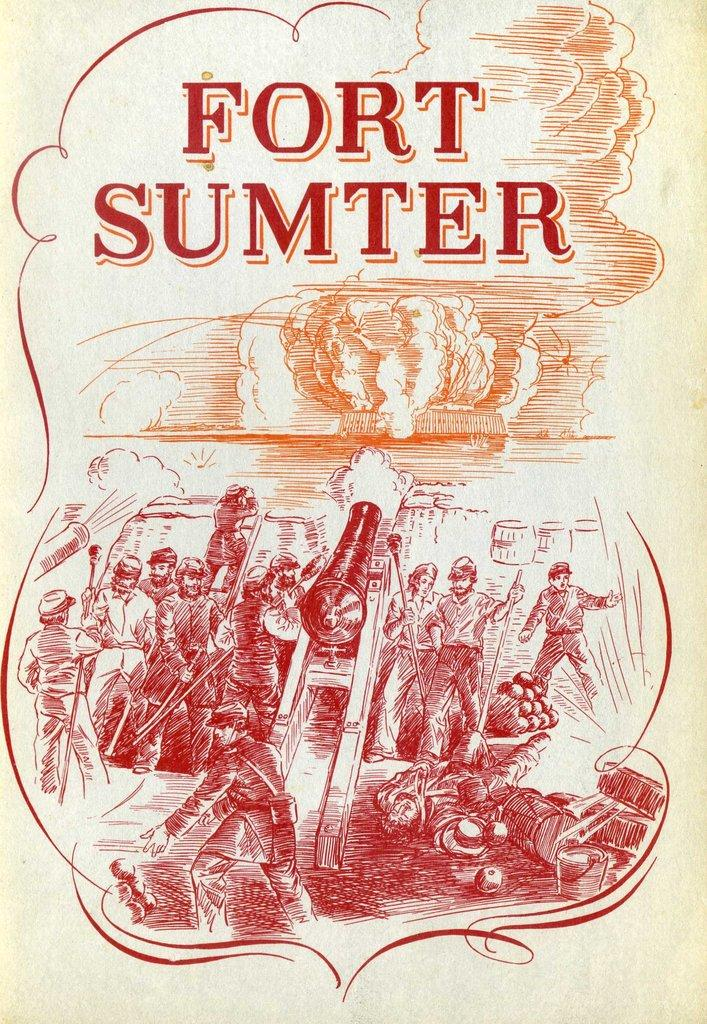<image>
Offer a succinct explanation of the picture presented. An old drawing which is called Fort Sumter. 